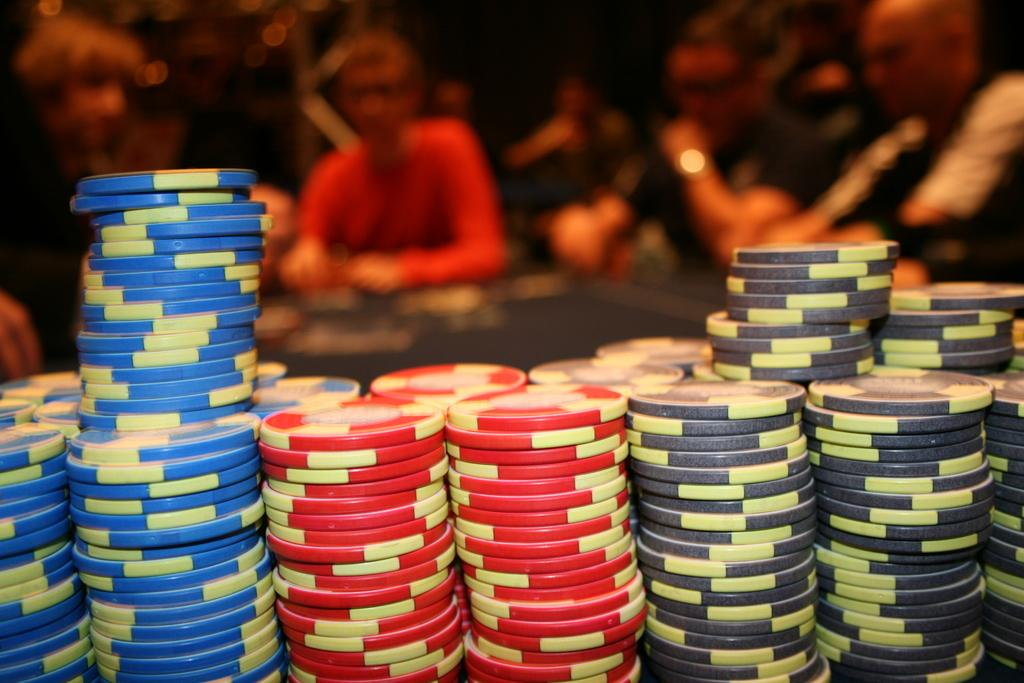What objects can be seen in the image? There are coins in the image. How are the coins arranged? The coins are arranged in rows. Can you describe the setting in the background of the image? There are people sitting around a table in the background of the image. Is there a tub filled with water in the image? No, there is no tub filled with water in the image. 